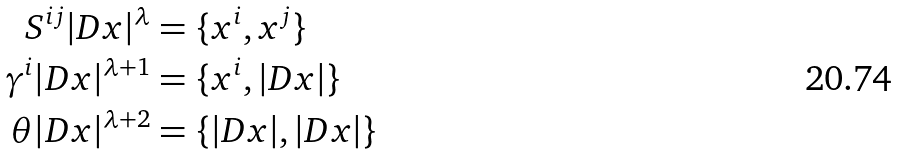<formula> <loc_0><loc_0><loc_500><loc_500>S ^ { i j } | D x | ^ { \lambda } & = \{ x ^ { i } , x ^ { j } \} \\ \gamma ^ { i } | D x | ^ { \lambda + 1 } & = \{ x ^ { i } , | D x | \} \\ \theta | D x | ^ { \lambda + 2 } & = \{ | D x | , | D x | \}</formula> 